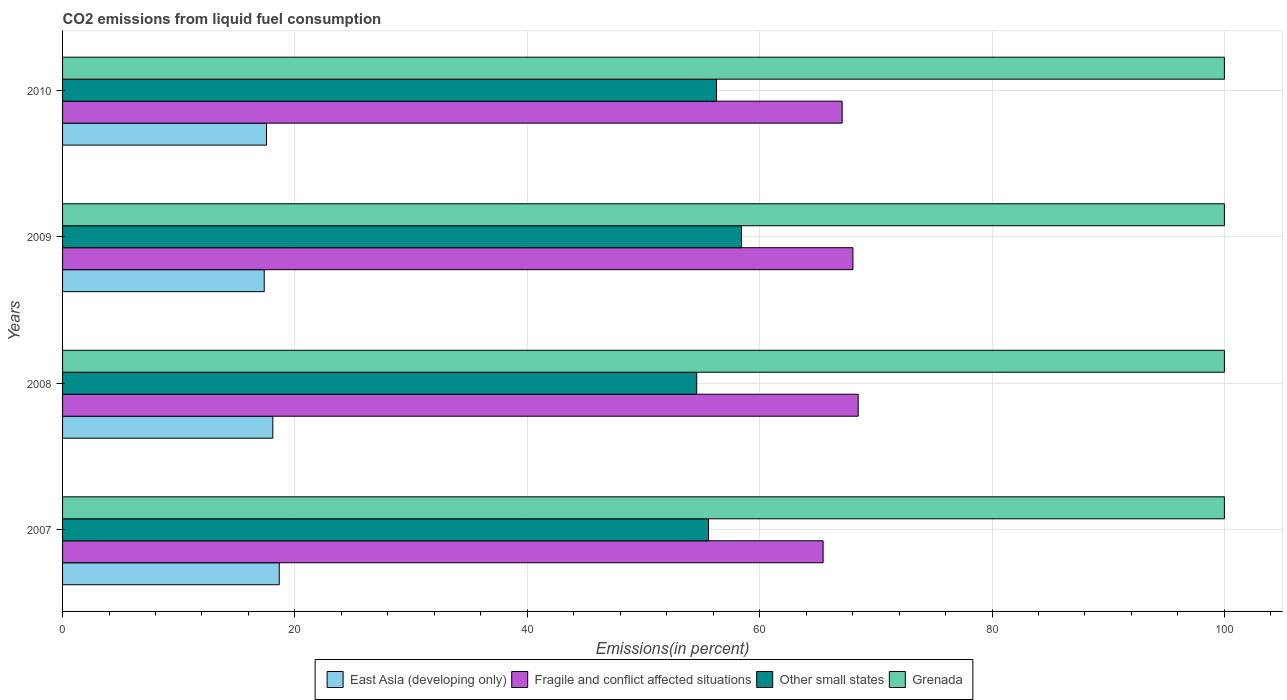How many groups of bars are there?
Make the answer very short. 4. Are the number of bars on each tick of the Y-axis equal?
Ensure brevity in your answer.  Yes. How many bars are there on the 1st tick from the bottom?
Offer a very short reply. 4. What is the total CO2 emitted in Other small states in 2008?
Your answer should be compact. 54.58. Across all years, what is the maximum total CO2 emitted in Other small states?
Keep it short and to the point. 58.44. Across all years, what is the minimum total CO2 emitted in Grenada?
Make the answer very short. 100. In which year was the total CO2 emitted in East Asia (developing only) maximum?
Ensure brevity in your answer.  2007. In which year was the total CO2 emitted in Fragile and conflict affected situations minimum?
Provide a succinct answer. 2007. What is the total total CO2 emitted in Grenada in the graph?
Make the answer very short. 400. What is the difference between the total CO2 emitted in East Asia (developing only) in 2007 and that in 2009?
Provide a succinct answer. 1.29. What is the difference between the total CO2 emitted in Grenada in 2010 and the total CO2 emitted in Other small states in 2009?
Keep it short and to the point. 41.56. What is the average total CO2 emitted in East Asia (developing only) per year?
Provide a short and direct response. 17.91. In the year 2009, what is the difference between the total CO2 emitted in Other small states and total CO2 emitted in Grenada?
Your response must be concise. -41.56. What is the ratio of the total CO2 emitted in Other small states in 2007 to that in 2009?
Your answer should be very brief. 0.95. Is the difference between the total CO2 emitted in Other small states in 2008 and 2010 greater than the difference between the total CO2 emitted in Grenada in 2008 and 2010?
Ensure brevity in your answer.  No. What is the difference between the highest and the lowest total CO2 emitted in Fragile and conflict affected situations?
Keep it short and to the point. 3.02. In how many years, is the total CO2 emitted in Other small states greater than the average total CO2 emitted in Other small states taken over all years?
Make the answer very short. 2. Is the sum of the total CO2 emitted in Grenada in 2007 and 2009 greater than the maximum total CO2 emitted in East Asia (developing only) across all years?
Your response must be concise. Yes. Is it the case that in every year, the sum of the total CO2 emitted in Fragile and conflict affected situations and total CO2 emitted in Grenada is greater than the sum of total CO2 emitted in East Asia (developing only) and total CO2 emitted in Other small states?
Your answer should be compact. No. What does the 4th bar from the top in 2010 represents?
Give a very brief answer. East Asia (developing only). What does the 3rd bar from the bottom in 2008 represents?
Offer a terse response. Other small states. Are all the bars in the graph horizontal?
Ensure brevity in your answer.  Yes. What is the difference between two consecutive major ticks on the X-axis?
Ensure brevity in your answer.  20. Are the values on the major ticks of X-axis written in scientific E-notation?
Keep it short and to the point. No. Does the graph contain any zero values?
Your answer should be very brief. No. How many legend labels are there?
Your answer should be compact. 4. How are the legend labels stacked?
Provide a short and direct response. Horizontal. What is the title of the graph?
Provide a succinct answer. CO2 emissions from liquid fuel consumption. Does "Comoros" appear as one of the legend labels in the graph?
Ensure brevity in your answer.  No. What is the label or title of the X-axis?
Keep it short and to the point. Emissions(in percent). What is the label or title of the Y-axis?
Your response must be concise. Years. What is the Emissions(in percent) in East Asia (developing only) in 2007?
Offer a very short reply. 18.65. What is the Emissions(in percent) in Fragile and conflict affected situations in 2007?
Ensure brevity in your answer.  65.46. What is the Emissions(in percent) in Other small states in 2007?
Keep it short and to the point. 55.6. What is the Emissions(in percent) of Grenada in 2007?
Provide a succinct answer. 100. What is the Emissions(in percent) of East Asia (developing only) in 2008?
Your response must be concise. 18.1. What is the Emissions(in percent) of Fragile and conflict affected situations in 2008?
Give a very brief answer. 68.48. What is the Emissions(in percent) of Other small states in 2008?
Your answer should be compact. 54.58. What is the Emissions(in percent) in Grenada in 2008?
Make the answer very short. 100. What is the Emissions(in percent) of East Asia (developing only) in 2009?
Provide a succinct answer. 17.36. What is the Emissions(in percent) in Fragile and conflict affected situations in 2009?
Provide a short and direct response. 68.03. What is the Emissions(in percent) of Other small states in 2009?
Offer a very short reply. 58.44. What is the Emissions(in percent) in Grenada in 2009?
Provide a succinct answer. 100. What is the Emissions(in percent) in East Asia (developing only) in 2010?
Your response must be concise. 17.55. What is the Emissions(in percent) in Fragile and conflict affected situations in 2010?
Ensure brevity in your answer.  67.1. What is the Emissions(in percent) in Other small states in 2010?
Provide a succinct answer. 56.29. What is the Emissions(in percent) of Grenada in 2010?
Keep it short and to the point. 100. Across all years, what is the maximum Emissions(in percent) of East Asia (developing only)?
Provide a short and direct response. 18.65. Across all years, what is the maximum Emissions(in percent) in Fragile and conflict affected situations?
Your answer should be very brief. 68.48. Across all years, what is the maximum Emissions(in percent) in Other small states?
Your response must be concise. 58.44. Across all years, what is the minimum Emissions(in percent) of East Asia (developing only)?
Your response must be concise. 17.36. Across all years, what is the minimum Emissions(in percent) in Fragile and conflict affected situations?
Give a very brief answer. 65.46. Across all years, what is the minimum Emissions(in percent) of Other small states?
Offer a very short reply. 54.58. What is the total Emissions(in percent) in East Asia (developing only) in the graph?
Offer a terse response. 71.66. What is the total Emissions(in percent) of Fragile and conflict affected situations in the graph?
Your response must be concise. 269.07. What is the total Emissions(in percent) of Other small states in the graph?
Your response must be concise. 224.9. What is the total Emissions(in percent) in Grenada in the graph?
Keep it short and to the point. 400. What is the difference between the Emissions(in percent) in East Asia (developing only) in 2007 and that in 2008?
Keep it short and to the point. 0.55. What is the difference between the Emissions(in percent) of Fragile and conflict affected situations in 2007 and that in 2008?
Provide a short and direct response. -3.02. What is the difference between the Emissions(in percent) in Other small states in 2007 and that in 2008?
Provide a short and direct response. 1.01. What is the difference between the Emissions(in percent) of Grenada in 2007 and that in 2008?
Ensure brevity in your answer.  0. What is the difference between the Emissions(in percent) of East Asia (developing only) in 2007 and that in 2009?
Provide a short and direct response. 1.29. What is the difference between the Emissions(in percent) in Fragile and conflict affected situations in 2007 and that in 2009?
Make the answer very short. -2.57. What is the difference between the Emissions(in percent) of Other small states in 2007 and that in 2009?
Provide a short and direct response. -2.84. What is the difference between the Emissions(in percent) of East Asia (developing only) in 2007 and that in 2010?
Your answer should be compact. 1.1. What is the difference between the Emissions(in percent) of Fragile and conflict affected situations in 2007 and that in 2010?
Give a very brief answer. -1.64. What is the difference between the Emissions(in percent) of Other small states in 2007 and that in 2010?
Make the answer very short. -0.69. What is the difference between the Emissions(in percent) of East Asia (developing only) in 2008 and that in 2009?
Make the answer very short. 0.74. What is the difference between the Emissions(in percent) in Fragile and conflict affected situations in 2008 and that in 2009?
Offer a terse response. 0.45. What is the difference between the Emissions(in percent) in Other small states in 2008 and that in 2009?
Make the answer very short. -3.85. What is the difference between the Emissions(in percent) in East Asia (developing only) in 2008 and that in 2010?
Ensure brevity in your answer.  0.54. What is the difference between the Emissions(in percent) in Fragile and conflict affected situations in 2008 and that in 2010?
Ensure brevity in your answer.  1.38. What is the difference between the Emissions(in percent) in Other small states in 2008 and that in 2010?
Keep it short and to the point. -1.7. What is the difference between the Emissions(in percent) in Grenada in 2008 and that in 2010?
Provide a succinct answer. 0. What is the difference between the Emissions(in percent) of East Asia (developing only) in 2009 and that in 2010?
Your answer should be very brief. -0.2. What is the difference between the Emissions(in percent) in Fragile and conflict affected situations in 2009 and that in 2010?
Give a very brief answer. 0.93. What is the difference between the Emissions(in percent) of Other small states in 2009 and that in 2010?
Your response must be concise. 2.15. What is the difference between the Emissions(in percent) of East Asia (developing only) in 2007 and the Emissions(in percent) of Fragile and conflict affected situations in 2008?
Give a very brief answer. -49.83. What is the difference between the Emissions(in percent) in East Asia (developing only) in 2007 and the Emissions(in percent) in Other small states in 2008?
Provide a succinct answer. -35.93. What is the difference between the Emissions(in percent) of East Asia (developing only) in 2007 and the Emissions(in percent) of Grenada in 2008?
Give a very brief answer. -81.35. What is the difference between the Emissions(in percent) of Fragile and conflict affected situations in 2007 and the Emissions(in percent) of Other small states in 2008?
Give a very brief answer. 10.88. What is the difference between the Emissions(in percent) of Fragile and conflict affected situations in 2007 and the Emissions(in percent) of Grenada in 2008?
Your answer should be compact. -34.54. What is the difference between the Emissions(in percent) in Other small states in 2007 and the Emissions(in percent) in Grenada in 2008?
Provide a short and direct response. -44.4. What is the difference between the Emissions(in percent) of East Asia (developing only) in 2007 and the Emissions(in percent) of Fragile and conflict affected situations in 2009?
Ensure brevity in your answer.  -49.38. What is the difference between the Emissions(in percent) in East Asia (developing only) in 2007 and the Emissions(in percent) in Other small states in 2009?
Your answer should be compact. -39.79. What is the difference between the Emissions(in percent) of East Asia (developing only) in 2007 and the Emissions(in percent) of Grenada in 2009?
Ensure brevity in your answer.  -81.35. What is the difference between the Emissions(in percent) of Fragile and conflict affected situations in 2007 and the Emissions(in percent) of Other small states in 2009?
Your answer should be compact. 7.03. What is the difference between the Emissions(in percent) of Fragile and conflict affected situations in 2007 and the Emissions(in percent) of Grenada in 2009?
Give a very brief answer. -34.54. What is the difference between the Emissions(in percent) in Other small states in 2007 and the Emissions(in percent) in Grenada in 2009?
Keep it short and to the point. -44.4. What is the difference between the Emissions(in percent) in East Asia (developing only) in 2007 and the Emissions(in percent) in Fragile and conflict affected situations in 2010?
Provide a short and direct response. -48.45. What is the difference between the Emissions(in percent) of East Asia (developing only) in 2007 and the Emissions(in percent) of Other small states in 2010?
Offer a terse response. -37.63. What is the difference between the Emissions(in percent) in East Asia (developing only) in 2007 and the Emissions(in percent) in Grenada in 2010?
Give a very brief answer. -81.35. What is the difference between the Emissions(in percent) in Fragile and conflict affected situations in 2007 and the Emissions(in percent) in Other small states in 2010?
Provide a succinct answer. 9.18. What is the difference between the Emissions(in percent) of Fragile and conflict affected situations in 2007 and the Emissions(in percent) of Grenada in 2010?
Your answer should be very brief. -34.54. What is the difference between the Emissions(in percent) of Other small states in 2007 and the Emissions(in percent) of Grenada in 2010?
Provide a succinct answer. -44.4. What is the difference between the Emissions(in percent) of East Asia (developing only) in 2008 and the Emissions(in percent) of Fragile and conflict affected situations in 2009?
Your answer should be compact. -49.93. What is the difference between the Emissions(in percent) in East Asia (developing only) in 2008 and the Emissions(in percent) in Other small states in 2009?
Keep it short and to the point. -40.34. What is the difference between the Emissions(in percent) of East Asia (developing only) in 2008 and the Emissions(in percent) of Grenada in 2009?
Your response must be concise. -81.9. What is the difference between the Emissions(in percent) of Fragile and conflict affected situations in 2008 and the Emissions(in percent) of Other small states in 2009?
Your answer should be very brief. 10.05. What is the difference between the Emissions(in percent) of Fragile and conflict affected situations in 2008 and the Emissions(in percent) of Grenada in 2009?
Give a very brief answer. -31.52. What is the difference between the Emissions(in percent) of Other small states in 2008 and the Emissions(in percent) of Grenada in 2009?
Provide a short and direct response. -45.42. What is the difference between the Emissions(in percent) of East Asia (developing only) in 2008 and the Emissions(in percent) of Fragile and conflict affected situations in 2010?
Provide a short and direct response. -49. What is the difference between the Emissions(in percent) of East Asia (developing only) in 2008 and the Emissions(in percent) of Other small states in 2010?
Make the answer very short. -38.19. What is the difference between the Emissions(in percent) of East Asia (developing only) in 2008 and the Emissions(in percent) of Grenada in 2010?
Your answer should be compact. -81.9. What is the difference between the Emissions(in percent) in Fragile and conflict affected situations in 2008 and the Emissions(in percent) in Other small states in 2010?
Your answer should be very brief. 12.2. What is the difference between the Emissions(in percent) in Fragile and conflict affected situations in 2008 and the Emissions(in percent) in Grenada in 2010?
Your answer should be very brief. -31.52. What is the difference between the Emissions(in percent) in Other small states in 2008 and the Emissions(in percent) in Grenada in 2010?
Provide a succinct answer. -45.42. What is the difference between the Emissions(in percent) of East Asia (developing only) in 2009 and the Emissions(in percent) of Fragile and conflict affected situations in 2010?
Your response must be concise. -49.74. What is the difference between the Emissions(in percent) in East Asia (developing only) in 2009 and the Emissions(in percent) in Other small states in 2010?
Keep it short and to the point. -38.93. What is the difference between the Emissions(in percent) of East Asia (developing only) in 2009 and the Emissions(in percent) of Grenada in 2010?
Ensure brevity in your answer.  -82.64. What is the difference between the Emissions(in percent) of Fragile and conflict affected situations in 2009 and the Emissions(in percent) of Other small states in 2010?
Make the answer very short. 11.74. What is the difference between the Emissions(in percent) in Fragile and conflict affected situations in 2009 and the Emissions(in percent) in Grenada in 2010?
Your response must be concise. -31.97. What is the difference between the Emissions(in percent) in Other small states in 2009 and the Emissions(in percent) in Grenada in 2010?
Keep it short and to the point. -41.56. What is the average Emissions(in percent) in East Asia (developing only) per year?
Provide a succinct answer. 17.91. What is the average Emissions(in percent) in Fragile and conflict affected situations per year?
Provide a short and direct response. 67.27. What is the average Emissions(in percent) in Other small states per year?
Offer a terse response. 56.23. In the year 2007, what is the difference between the Emissions(in percent) in East Asia (developing only) and Emissions(in percent) in Fragile and conflict affected situations?
Offer a very short reply. -46.81. In the year 2007, what is the difference between the Emissions(in percent) in East Asia (developing only) and Emissions(in percent) in Other small states?
Provide a succinct answer. -36.95. In the year 2007, what is the difference between the Emissions(in percent) of East Asia (developing only) and Emissions(in percent) of Grenada?
Keep it short and to the point. -81.35. In the year 2007, what is the difference between the Emissions(in percent) of Fragile and conflict affected situations and Emissions(in percent) of Other small states?
Make the answer very short. 9.86. In the year 2007, what is the difference between the Emissions(in percent) in Fragile and conflict affected situations and Emissions(in percent) in Grenada?
Give a very brief answer. -34.54. In the year 2007, what is the difference between the Emissions(in percent) in Other small states and Emissions(in percent) in Grenada?
Ensure brevity in your answer.  -44.4. In the year 2008, what is the difference between the Emissions(in percent) of East Asia (developing only) and Emissions(in percent) of Fragile and conflict affected situations?
Provide a short and direct response. -50.39. In the year 2008, what is the difference between the Emissions(in percent) in East Asia (developing only) and Emissions(in percent) in Other small states?
Offer a terse response. -36.49. In the year 2008, what is the difference between the Emissions(in percent) of East Asia (developing only) and Emissions(in percent) of Grenada?
Offer a terse response. -81.9. In the year 2008, what is the difference between the Emissions(in percent) in Fragile and conflict affected situations and Emissions(in percent) in Other small states?
Give a very brief answer. 13.9. In the year 2008, what is the difference between the Emissions(in percent) of Fragile and conflict affected situations and Emissions(in percent) of Grenada?
Give a very brief answer. -31.52. In the year 2008, what is the difference between the Emissions(in percent) of Other small states and Emissions(in percent) of Grenada?
Ensure brevity in your answer.  -45.42. In the year 2009, what is the difference between the Emissions(in percent) in East Asia (developing only) and Emissions(in percent) in Fragile and conflict affected situations?
Keep it short and to the point. -50.67. In the year 2009, what is the difference between the Emissions(in percent) in East Asia (developing only) and Emissions(in percent) in Other small states?
Ensure brevity in your answer.  -41.08. In the year 2009, what is the difference between the Emissions(in percent) of East Asia (developing only) and Emissions(in percent) of Grenada?
Give a very brief answer. -82.64. In the year 2009, what is the difference between the Emissions(in percent) of Fragile and conflict affected situations and Emissions(in percent) of Other small states?
Keep it short and to the point. 9.59. In the year 2009, what is the difference between the Emissions(in percent) in Fragile and conflict affected situations and Emissions(in percent) in Grenada?
Offer a very short reply. -31.97. In the year 2009, what is the difference between the Emissions(in percent) of Other small states and Emissions(in percent) of Grenada?
Provide a succinct answer. -41.56. In the year 2010, what is the difference between the Emissions(in percent) of East Asia (developing only) and Emissions(in percent) of Fragile and conflict affected situations?
Offer a very short reply. -49.55. In the year 2010, what is the difference between the Emissions(in percent) in East Asia (developing only) and Emissions(in percent) in Other small states?
Make the answer very short. -38.73. In the year 2010, what is the difference between the Emissions(in percent) of East Asia (developing only) and Emissions(in percent) of Grenada?
Provide a succinct answer. -82.45. In the year 2010, what is the difference between the Emissions(in percent) in Fragile and conflict affected situations and Emissions(in percent) in Other small states?
Give a very brief answer. 10.81. In the year 2010, what is the difference between the Emissions(in percent) in Fragile and conflict affected situations and Emissions(in percent) in Grenada?
Your response must be concise. -32.9. In the year 2010, what is the difference between the Emissions(in percent) in Other small states and Emissions(in percent) in Grenada?
Give a very brief answer. -43.71. What is the ratio of the Emissions(in percent) in East Asia (developing only) in 2007 to that in 2008?
Your response must be concise. 1.03. What is the ratio of the Emissions(in percent) of Fragile and conflict affected situations in 2007 to that in 2008?
Your answer should be compact. 0.96. What is the ratio of the Emissions(in percent) of Other small states in 2007 to that in 2008?
Keep it short and to the point. 1.02. What is the ratio of the Emissions(in percent) of Grenada in 2007 to that in 2008?
Keep it short and to the point. 1. What is the ratio of the Emissions(in percent) in East Asia (developing only) in 2007 to that in 2009?
Your answer should be very brief. 1.07. What is the ratio of the Emissions(in percent) in Fragile and conflict affected situations in 2007 to that in 2009?
Your answer should be compact. 0.96. What is the ratio of the Emissions(in percent) in Other small states in 2007 to that in 2009?
Provide a succinct answer. 0.95. What is the ratio of the Emissions(in percent) of East Asia (developing only) in 2007 to that in 2010?
Provide a short and direct response. 1.06. What is the ratio of the Emissions(in percent) in Fragile and conflict affected situations in 2007 to that in 2010?
Provide a succinct answer. 0.98. What is the ratio of the Emissions(in percent) of Other small states in 2007 to that in 2010?
Offer a very short reply. 0.99. What is the ratio of the Emissions(in percent) in East Asia (developing only) in 2008 to that in 2009?
Ensure brevity in your answer.  1.04. What is the ratio of the Emissions(in percent) in Fragile and conflict affected situations in 2008 to that in 2009?
Ensure brevity in your answer.  1.01. What is the ratio of the Emissions(in percent) in Other small states in 2008 to that in 2009?
Keep it short and to the point. 0.93. What is the ratio of the Emissions(in percent) of East Asia (developing only) in 2008 to that in 2010?
Your response must be concise. 1.03. What is the ratio of the Emissions(in percent) in Fragile and conflict affected situations in 2008 to that in 2010?
Your response must be concise. 1.02. What is the ratio of the Emissions(in percent) in Other small states in 2008 to that in 2010?
Keep it short and to the point. 0.97. What is the ratio of the Emissions(in percent) in East Asia (developing only) in 2009 to that in 2010?
Offer a terse response. 0.99. What is the ratio of the Emissions(in percent) of Fragile and conflict affected situations in 2009 to that in 2010?
Provide a short and direct response. 1.01. What is the ratio of the Emissions(in percent) in Other small states in 2009 to that in 2010?
Ensure brevity in your answer.  1.04. What is the ratio of the Emissions(in percent) of Grenada in 2009 to that in 2010?
Offer a terse response. 1. What is the difference between the highest and the second highest Emissions(in percent) of East Asia (developing only)?
Your response must be concise. 0.55. What is the difference between the highest and the second highest Emissions(in percent) in Fragile and conflict affected situations?
Your answer should be compact. 0.45. What is the difference between the highest and the second highest Emissions(in percent) in Other small states?
Your answer should be very brief. 2.15. What is the difference between the highest and the lowest Emissions(in percent) in East Asia (developing only)?
Provide a succinct answer. 1.29. What is the difference between the highest and the lowest Emissions(in percent) in Fragile and conflict affected situations?
Offer a terse response. 3.02. What is the difference between the highest and the lowest Emissions(in percent) of Other small states?
Provide a short and direct response. 3.85. 